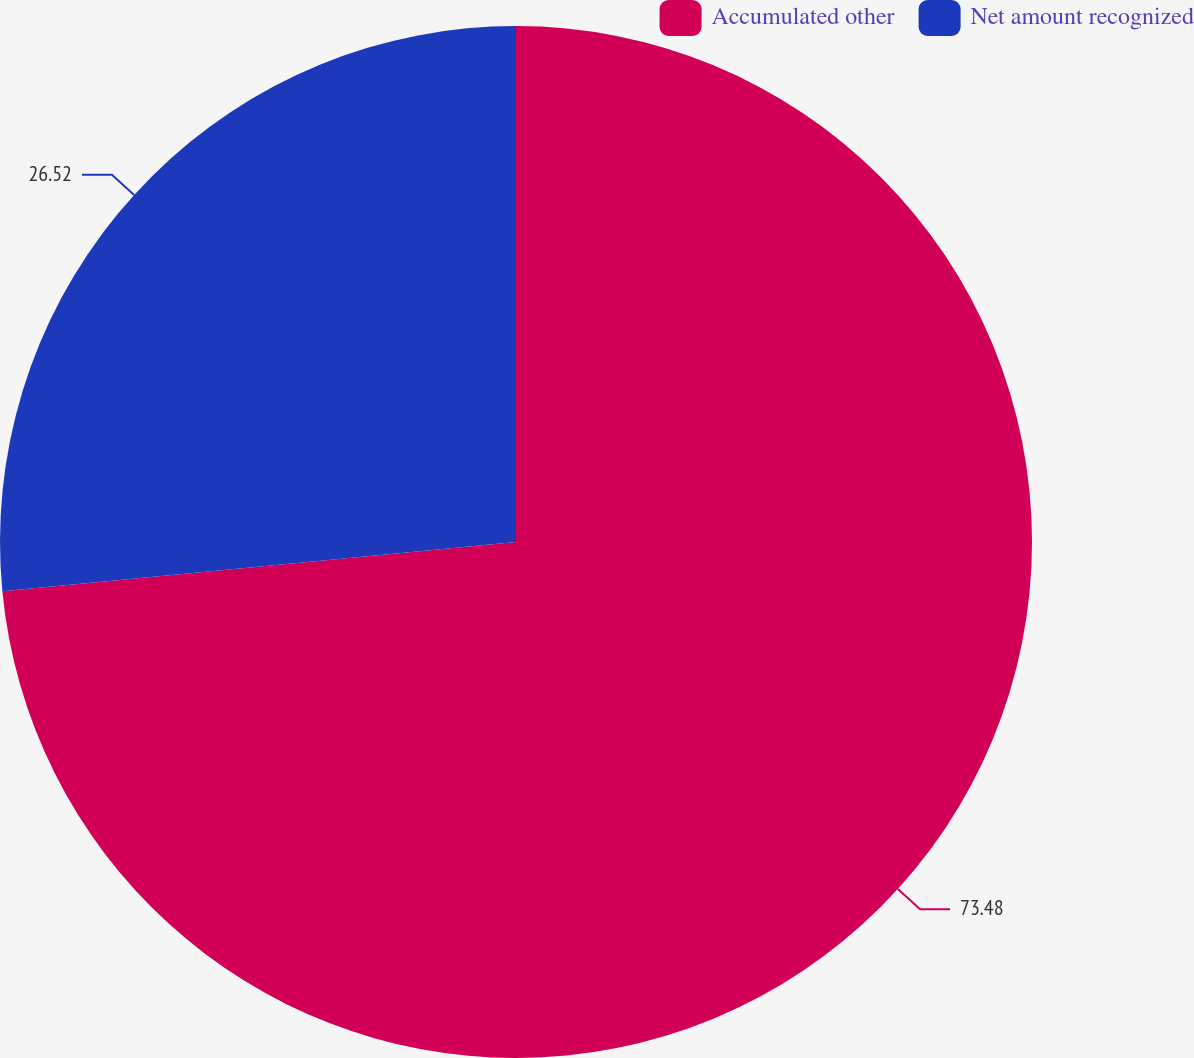<chart> <loc_0><loc_0><loc_500><loc_500><pie_chart><fcel>Accumulated other<fcel>Net amount recognized<nl><fcel>73.48%<fcel>26.52%<nl></chart> 